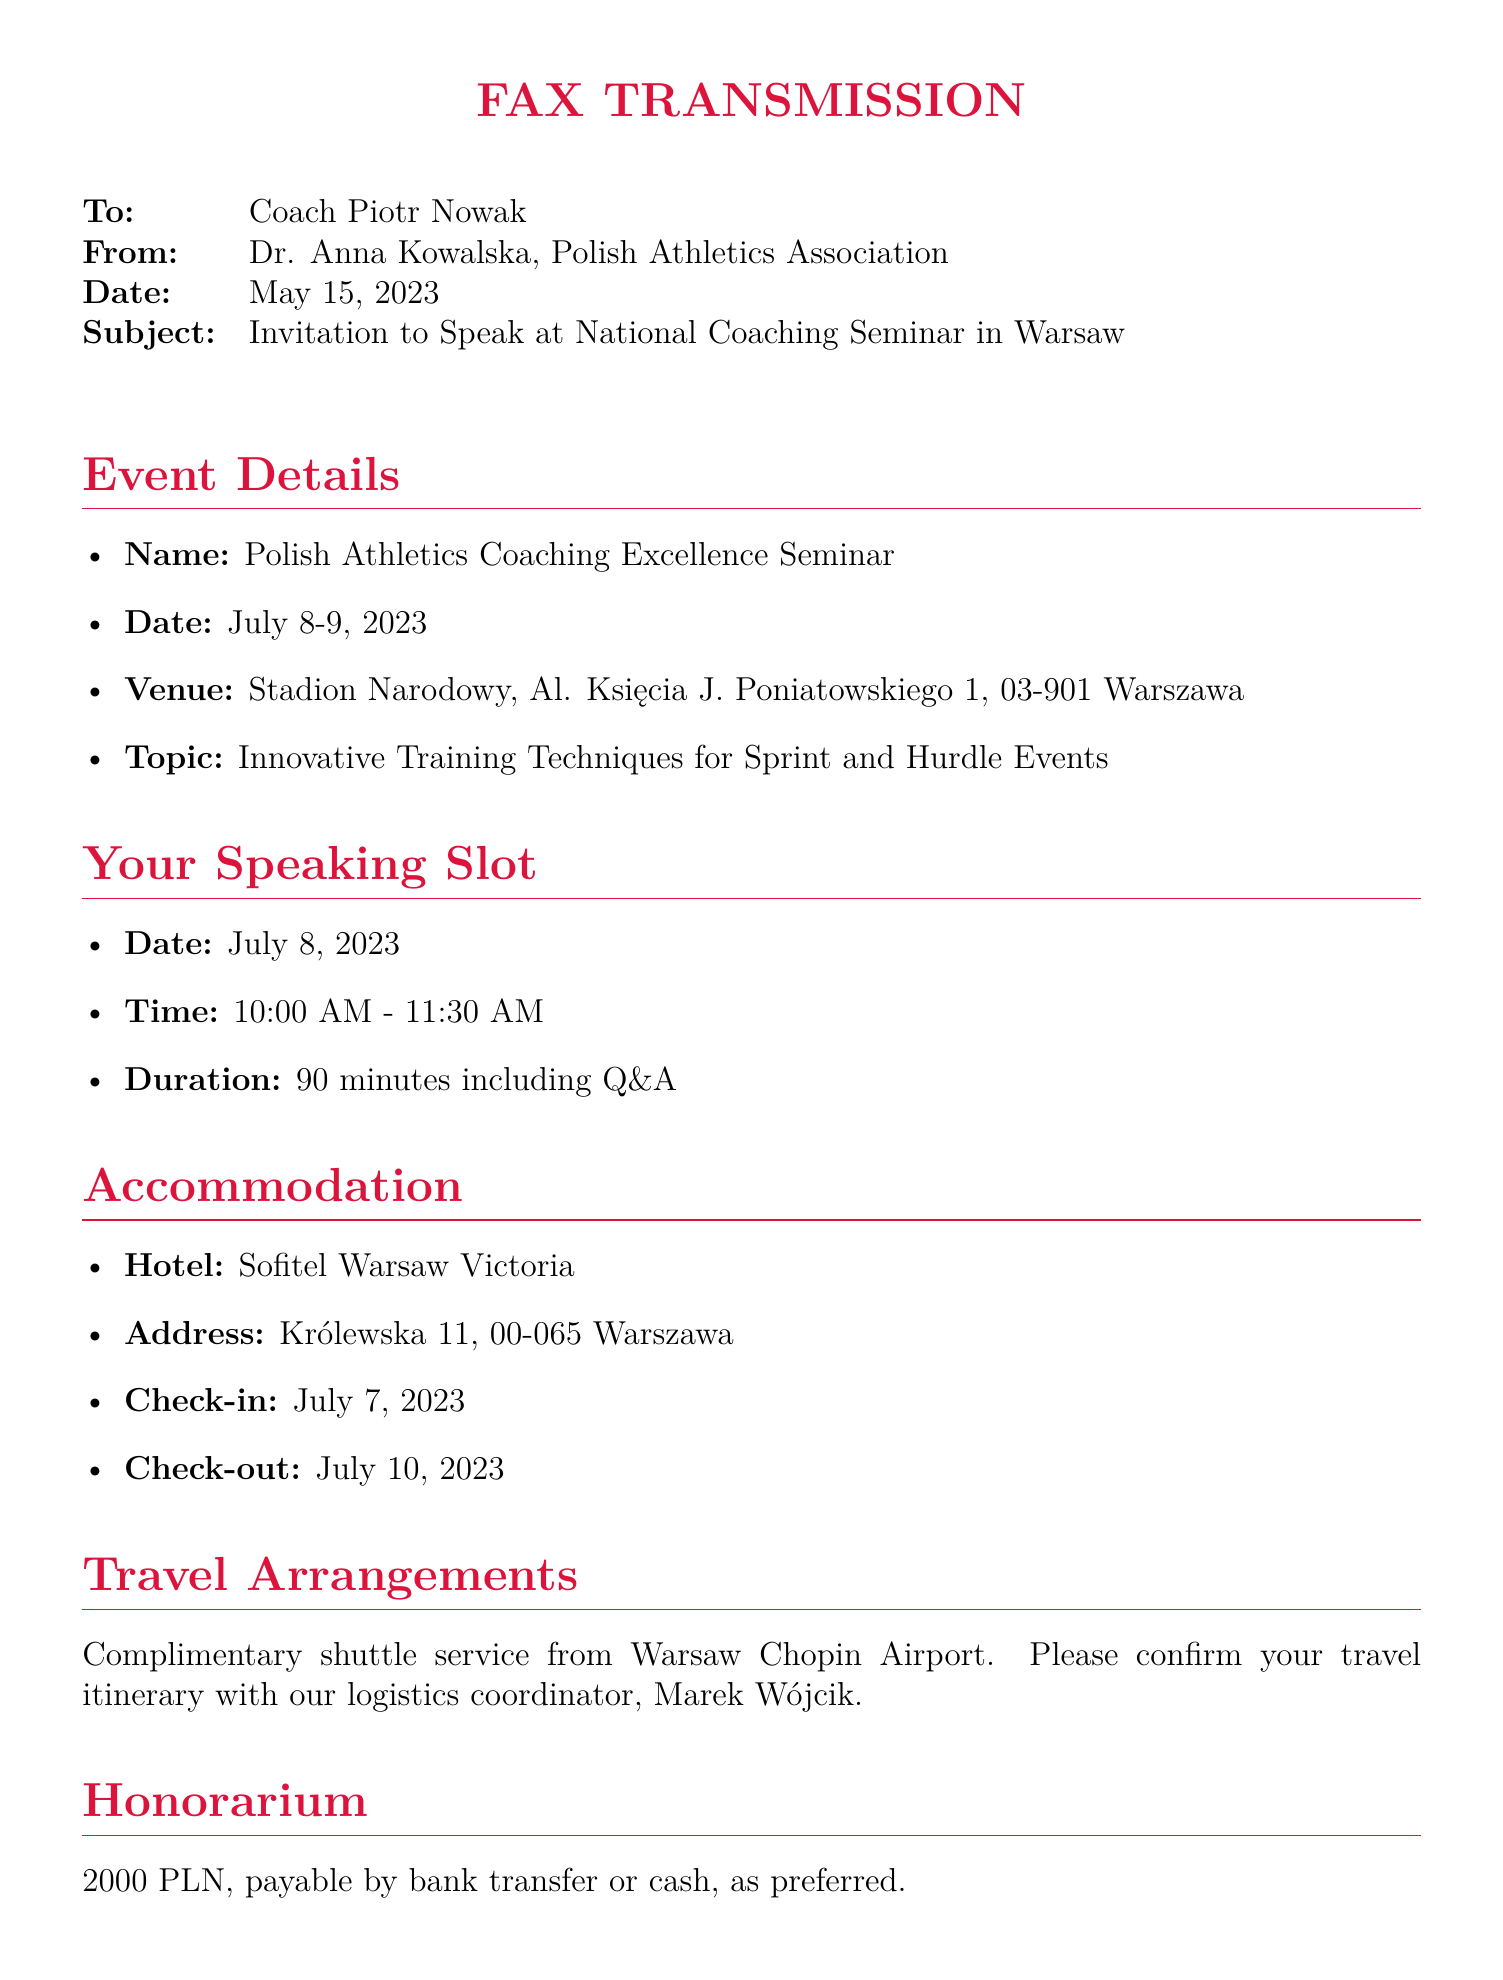What is the name of the seminar? The document specifies the name of the seminar as "Polish Athletics Coaching Excellence Seminar."
Answer: Polish Athletics Coaching Excellence Seminar What are the seminar dates? The event dates are mentioned in the document as July 8-9, 2023.
Answer: July 8-9, 2023 Who is the sender of the fax? The sender's name, as listed in the document, is Dr. Anna Kowalska.
Answer: Dr. Anna Kowalska What is the duration of your speaking slot? The duration of the speaking slot is specified in the document as 90 minutes including Q&A.
Answer: 90 minutes What is the honorarium amount? The document states the honorarium amount as 2000 PLN.
Answer: 2000 PLN When is the RSVP deadline? The RSVP deadline is outlined in the document as May 31, 2023.
Answer: May 31, 2023 Where is the venue located? The venue address is provided as Stadion Narodowy, Al. Księcia J. Poniatowskiego 1, 03-901 Warszawa.
Answer: Stadion Narodowy, Al. Księcia J. Poniatowskiego 1, 03-901 Warszawa What is included in travel arrangements? The document mentions that there is a complimentary shuttle service from Warsaw Chopin Airport.
Answer: Complimentary shuttle service What is the check-out date at the hotel? The check-out date for the hotel is noted in the document as July 10, 2023.
Answer: July 10, 2023 